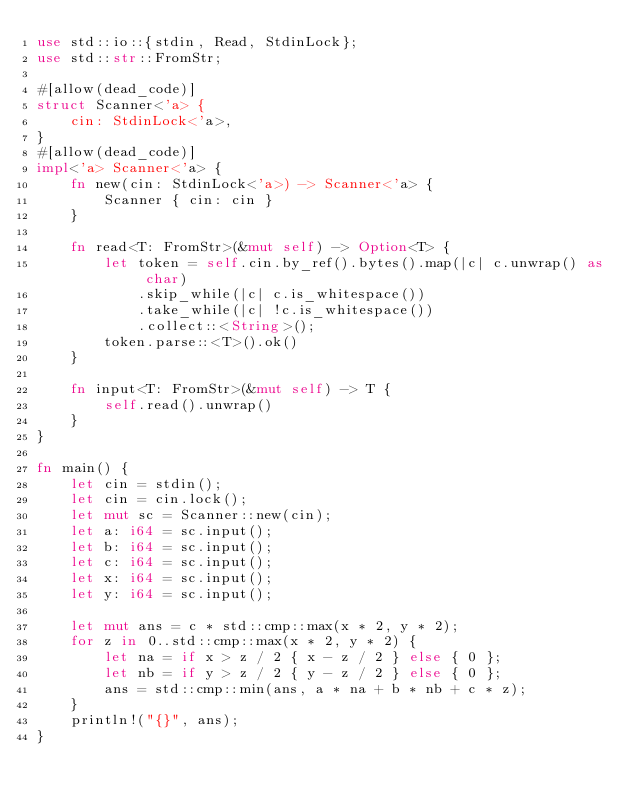<code> <loc_0><loc_0><loc_500><loc_500><_Rust_>use std::io::{stdin, Read, StdinLock};
use std::str::FromStr;

#[allow(dead_code)]
struct Scanner<'a> {
    cin: StdinLock<'a>,
}
#[allow(dead_code)]
impl<'a> Scanner<'a> {
    fn new(cin: StdinLock<'a>) -> Scanner<'a> {
        Scanner { cin: cin }
    }

    fn read<T: FromStr>(&mut self) -> Option<T> {
        let token = self.cin.by_ref().bytes().map(|c| c.unwrap() as char)
            .skip_while(|c| c.is_whitespace())
            .take_while(|c| !c.is_whitespace())
            .collect::<String>();
        token.parse::<T>().ok()
    }

    fn input<T: FromStr>(&mut self) -> T {
        self.read().unwrap()
    }
}

fn main() {
    let cin = stdin();
    let cin = cin.lock();
    let mut sc = Scanner::new(cin);
    let a: i64 = sc.input();
    let b: i64 = sc.input();
    let c: i64 = sc.input();
    let x: i64 = sc.input();
    let y: i64 = sc.input();

    let mut ans = c * std::cmp::max(x * 2, y * 2);
    for z in 0..std::cmp::max(x * 2, y * 2) {
        let na = if x > z / 2 { x - z / 2 } else { 0 };
        let nb = if y > z / 2 { y - z / 2 } else { 0 };
        ans = std::cmp::min(ans, a * na + b * nb + c * z);
    }
    println!("{}", ans);
}
</code> 